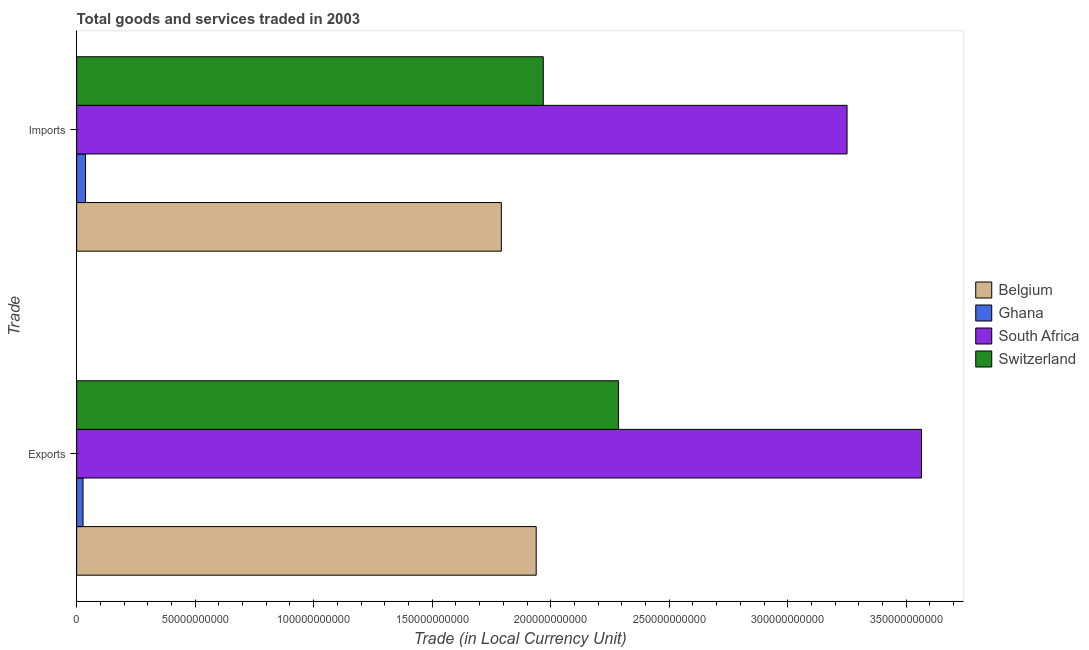How many different coloured bars are there?
Your answer should be very brief. 4. How many bars are there on the 1st tick from the bottom?
Give a very brief answer. 4. What is the label of the 2nd group of bars from the top?
Give a very brief answer. Exports. What is the export of goods and services in Ghana?
Ensure brevity in your answer.  2.69e+09. Across all countries, what is the maximum export of goods and services?
Make the answer very short. 3.56e+11. Across all countries, what is the minimum imports of goods and services?
Your response must be concise. 3.75e+09. In which country was the imports of goods and services maximum?
Keep it short and to the point. South Africa. In which country was the export of goods and services minimum?
Keep it short and to the point. Ghana. What is the total imports of goods and services in the graph?
Keep it short and to the point. 7.05e+11. What is the difference between the export of goods and services in Ghana and that in Belgium?
Give a very brief answer. -1.91e+11. What is the difference between the export of goods and services in Belgium and the imports of goods and services in South Africa?
Give a very brief answer. -1.31e+11. What is the average imports of goods and services per country?
Your answer should be compact. 1.76e+11. What is the difference between the imports of goods and services and export of goods and services in South Africa?
Your answer should be very brief. -3.14e+1. In how many countries, is the export of goods and services greater than 260000000000 LCU?
Ensure brevity in your answer.  1. What is the ratio of the imports of goods and services in Ghana to that in Belgium?
Your response must be concise. 0.02. In how many countries, is the imports of goods and services greater than the average imports of goods and services taken over all countries?
Make the answer very short. 3. What does the 3rd bar from the top in Imports represents?
Give a very brief answer. Ghana. What does the 1st bar from the bottom in Imports represents?
Your response must be concise. Belgium. What is the difference between two consecutive major ticks on the X-axis?
Keep it short and to the point. 5.00e+1. Where does the legend appear in the graph?
Keep it short and to the point. Center right. How many legend labels are there?
Ensure brevity in your answer.  4. What is the title of the graph?
Provide a short and direct response. Total goods and services traded in 2003. What is the label or title of the X-axis?
Give a very brief answer. Trade (in Local Currency Unit). What is the label or title of the Y-axis?
Make the answer very short. Trade. What is the Trade (in Local Currency Unit) of Belgium in Exports?
Make the answer very short. 1.94e+11. What is the Trade (in Local Currency Unit) of Ghana in Exports?
Offer a very short reply. 2.69e+09. What is the Trade (in Local Currency Unit) in South Africa in Exports?
Give a very brief answer. 3.56e+11. What is the Trade (in Local Currency Unit) in Switzerland in Exports?
Offer a terse response. 2.29e+11. What is the Trade (in Local Currency Unit) of Belgium in Imports?
Your answer should be compact. 1.79e+11. What is the Trade (in Local Currency Unit) in Ghana in Imports?
Give a very brief answer. 3.75e+09. What is the Trade (in Local Currency Unit) in South Africa in Imports?
Provide a short and direct response. 3.25e+11. What is the Trade (in Local Currency Unit) of Switzerland in Imports?
Your answer should be compact. 1.97e+11. Across all Trade, what is the maximum Trade (in Local Currency Unit) in Belgium?
Your answer should be very brief. 1.94e+11. Across all Trade, what is the maximum Trade (in Local Currency Unit) in Ghana?
Your response must be concise. 3.75e+09. Across all Trade, what is the maximum Trade (in Local Currency Unit) in South Africa?
Your response must be concise. 3.56e+11. Across all Trade, what is the maximum Trade (in Local Currency Unit) of Switzerland?
Provide a short and direct response. 2.29e+11. Across all Trade, what is the minimum Trade (in Local Currency Unit) in Belgium?
Provide a succinct answer. 1.79e+11. Across all Trade, what is the minimum Trade (in Local Currency Unit) of Ghana?
Your answer should be very brief. 2.69e+09. Across all Trade, what is the minimum Trade (in Local Currency Unit) in South Africa?
Your answer should be compact. 3.25e+11. Across all Trade, what is the minimum Trade (in Local Currency Unit) in Switzerland?
Your answer should be compact. 1.97e+11. What is the total Trade (in Local Currency Unit) of Belgium in the graph?
Ensure brevity in your answer.  3.73e+11. What is the total Trade (in Local Currency Unit) in Ghana in the graph?
Provide a succinct answer. 6.44e+09. What is the total Trade (in Local Currency Unit) of South Africa in the graph?
Your answer should be compact. 6.81e+11. What is the total Trade (in Local Currency Unit) of Switzerland in the graph?
Give a very brief answer. 4.25e+11. What is the difference between the Trade (in Local Currency Unit) in Belgium in Exports and that in Imports?
Keep it short and to the point. 1.47e+1. What is the difference between the Trade (in Local Currency Unit) in Ghana in Exports and that in Imports?
Make the answer very short. -1.05e+09. What is the difference between the Trade (in Local Currency Unit) in South Africa in Exports and that in Imports?
Keep it short and to the point. 3.14e+1. What is the difference between the Trade (in Local Currency Unit) in Switzerland in Exports and that in Imports?
Provide a short and direct response. 3.18e+1. What is the difference between the Trade (in Local Currency Unit) of Belgium in Exports and the Trade (in Local Currency Unit) of Ghana in Imports?
Keep it short and to the point. 1.90e+11. What is the difference between the Trade (in Local Currency Unit) of Belgium in Exports and the Trade (in Local Currency Unit) of South Africa in Imports?
Make the answer very short. -1.31e+11. What is the difference between the Trade (in Local Currency Unit) in Belgium in Exports and the Trade (in Local Currency Unit) in Switzerland in Imports?
Make the answer very short. -2.99e+09. What is the difference between the Trade (in Local Currency Unit) in Ghana in Exports and the Trade (in Local Currency Unit) in South Africa in Imports?
Your response must be concise. -3.22e+11. What is the difference between the Trade (in Local Currency Unit) in Ghana in Exports and the Trade (in Local Currency Unit) in Switzerland in Imports?
Your response must be concise. -1.94e+11. What is the difference between the Trade (in Local Currency Unit) of South Africa in Exports and the Trade (in Local Currency Unit) of Switzerland in Imports?
Provide a short and direct response. 1.60e+11. What is the average Trade (in Local Currency Unit) of Belgium per Trade?
Your answer should be very brief. 1.87e+11. What is the average Trade (in Local Currency Unit) in Ghana per Trade?
Give a very brief answer. 3.22e+09. What is the average Trade (in Local Currency Unit) of South Africa per Trade?
Your answer should be compact. 3.41e+11. What is the average Trade (in Local Currency Unit) of Switzerland per Trade?
Provide a short and direct response. 2.13e+11. What is the difference between the Trade (in Local Currency Unit) in Belgium and Trade (in Local Currency Unit) in Ghana in Exports?
Offer a very short reply. 1.91e+11. What is the difference between the Trade (in Local Currency Unit) of Belgium and Trade (in Local Currency Unit) of South Africa in Exports?
Offer a terse response. -1.63e+11. What is the difference between the Trade (in Local Currency Unit) of Belgium and Trade (in Local Currency Unit) of Switzerland in Exports?
Your answer should be compact. -3.47e+1. What is the difference between the Trade (in Local Currency Unit) of Ghana and Trade (in Local Currency Unit) of South Africa in Exports?
Offer a terse response. -3.54e+11. What is the difference between the Trade (in Local Currency Unit) of Ghana and Trade (in Local Currency Unit) of Switzerland in Exports?
Provide a succinct answer. -2.26e+11. What is the difference between the Trade (in Local Currency Unit) of South Africa and Trade (in Local Currency Unit) of Switzerland in Exports?
Ensure brevity in your answer.  1.28e+11. What is the difference between the Trade (in Local Currency Unit) of Belgium and Trade (in Local Currency Unit) of Ghana in Imports?
Your answer should be very brief. 1.75e+11. What is the difference between the Trade (in Local Currency Unit) of Belgium and Trade (in Local Currency Unit) of South Africa in Imports?
Your answer should be compact. -1.46e+11. What is the difference between the Trade (in Local Currency Unit) in Belgium and Trade (in Local Currency Unit) in Switzerland in Imports?
Provide a succinct answer. -1.77e+1. What is the difference between the Trade (in Local Currency Unit) in Ghana and Trade (in Local Currency Unit) in South Africa in Imports?
Offer a very short reply. -3.21e+11. What is the difference between the Trade (in Local Currency Unit) in Ghana and Trade (in Local Currency Unit) in Switzerland in Imports?
Your response must be concise. -1.93e+11. What is the difference between the Trade (in Local Currency Unit) of South Africa and Trade (in Local Currency Unit) of Switzerland in Imports?
Give a very brief answer. 1.28e+11. What is the ratio of the Trade (in Local Currency Unit) in Belgium in Exports to that in Imports?
Offer a very short reply. 1.08. What is the ratio of the Trade (in Local Currency Unit) of Ghana in Exports to that in Imports?
Give a very brief answer. 0.72. What is the ratio of the Trade (in Local Currency Unit) of South Africa in Exports to that in Imports?
Provide a succinct answer. 1.1. What is the ratio of the Trade (in Local Currency Unit) of Switzerland in Exports to that in Imports?
Your answer should be very brief. 1.16. What is the difference between the highest and the second highest Trade (in Local Currency Unit) in Belgium?
Your response must be concise. 1.47e+1. What is the difference between the highest and the second highest Trade (in Local Currency Unit) of Ghana?
Ensure brevity in your answer.  1.05e+09. What is the difference between the highest and the second highest Trade (in Local Currency Unit) in South Africa?
Your answer should be very brief. 3.14e+1. What is the difference between the highest and the second highest Trade (in Local Currency Unit) in Switzerland?
Give a very brief answer. 3.18e+1. What is the difference between the highest and the lowest Trade (in Local Currency Unit) of Belgium?
Your response must be concise. 1.47e+1. What is the difference between the highest and the lowest Trade (in Local Currency Unit) of Ghana?
Your answer should be very brief. 1.05e+09. What is the difference between the highest and the lowest Trade (in Local Currency Unit) in South Africa?
Keep it short and to the point. 3.14e+1. What is the difference between the highest and the lowest Trade (in Local Currency Unit) of Switzerland?
Provide a short and direct response. 3.18e+1. 